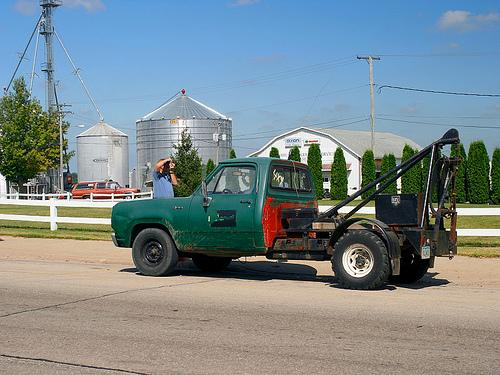What color was this truck originally?

Choices:
A) red
B) green
C) yellow
D) blue red 